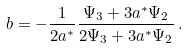<formula> <loc_0><loc_0><loc_500><loc_500>b = - \frac { 1 } { 2 a ^ { * } } \frac { \Psi _ { 3 } + 3 a ^ { * } \Psi _ { 2 } } { 2 \Psi _ { 3 } + 3 a ^ { * } \Psi _ { 2 } } \, .</formula> 